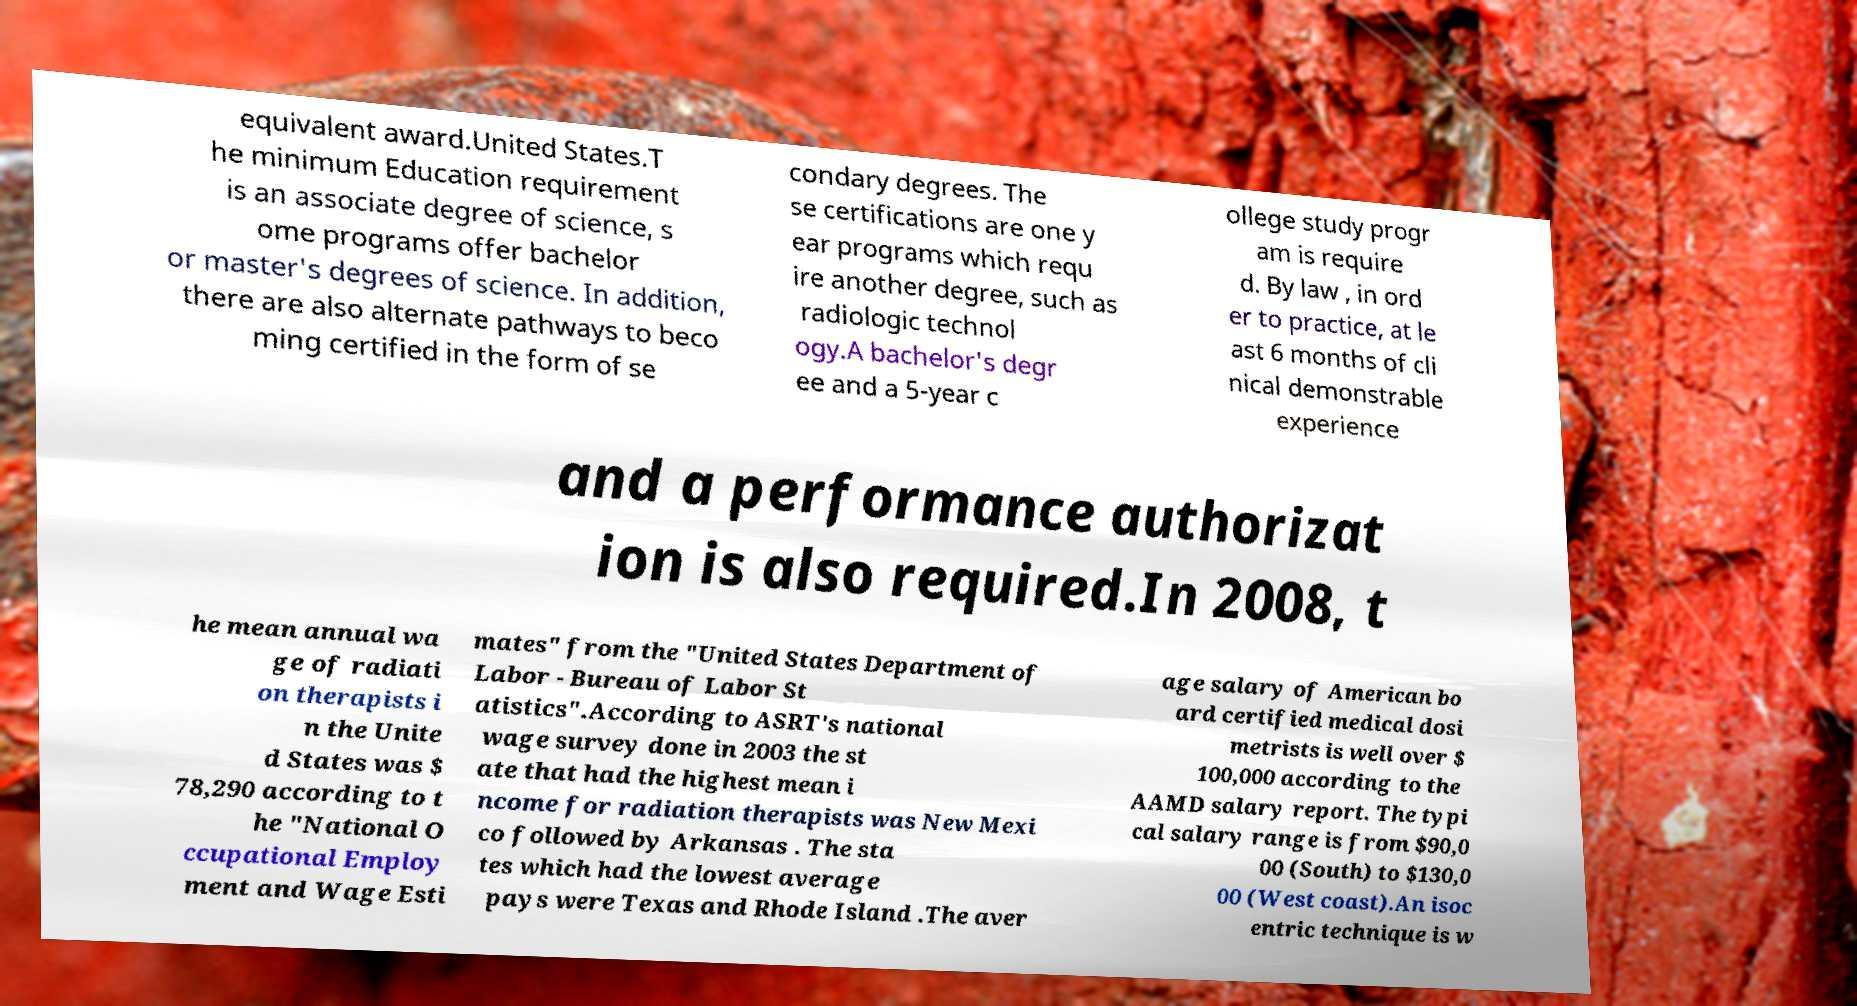Could you extract and type out the text from this image? equivalent award.United States.T he minimum Education requirement is an associate degree of science, s ome programs offer bachelor or master's degrees of science. In addition, there are also alternate pathways to beco ming certified in the form of se condary degrees. The se certifications are one y ear programs which requ ire another degree, such as radiologic technol ogy.A bachelor's degr ee and a 5-year c ollege study progr am is require d. By law , in ord er to practice, at le ast 6 months of cli nical demonstrable experience and a performance authorizat ion is also required.In 2008, t he mean annual wa ge of radiati on therapists i n the Unite d States was $ 78,290 according to t he "National O ccupational Employ ment and Wage Esti mates" from the "United States Department of Labor - Bureau of Labor St atistics".According to ASRT's national wage survey done in 2003 the st ate that had the highest mean i ncome for radiation therapists was New Mexi co followed by Arkansas . The sta tes which had the lowest average pays were Texas and Rhode Island .The aver age salary of American bo ard certified medical dosi metrists is well over $ 100,000 according to the AAMD salary report. The typi cal salary range is from $90,0 00 (South) to $130,0 00 (West coast).An isoc entric technique is w 